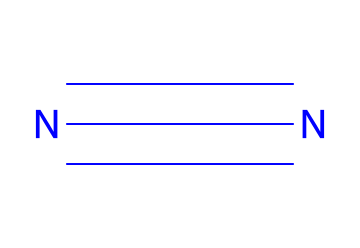What is the molecular formula of nitrogen gas? The SMILES representation (N#N) indicates two nitrogen atoms connected by a triple bond. Thus, the molecular formula is derived directly from counting these atoms.
Answer: N2 How many atoms are present in nitrogen gas? From the SMILES structure (N#N), we can observe that there are two nitrogen atoms. Therefore, the total number of atoms in nitrogen gas is simply the count of nitrogen present.
Answer: 2 What kind of bond exists between the nitrogen atoms? The representation "N#N" indicates a triple bond between the two nitrogen atoms. This is seen in the notation where the '#' symbol represents the triple bond linkage.
Answer: triple bond Why is nitrogen gas used for inflating footballs? Nitrogen gas is used to inflate footballs primarily due to its inertness; it does not react readily with other materials, ensuring stability and preserving pressure over time.
Answer: inert Is nitrogen gas lighter or heavier than air? Nitrogen gas has a lower density compared to the average density of air; this means it is lighter than air. This property is due to the composition of nitrogen gas and the molecular weight of air.
Answer: lighter What is the common state of nitrogen gas at room temperature? At room temperature and standard atmospheric pressure, nitrogen exists as a gas, which is indicated by its molecular structure and common properties in multiple states of matter.
Answer: gas 